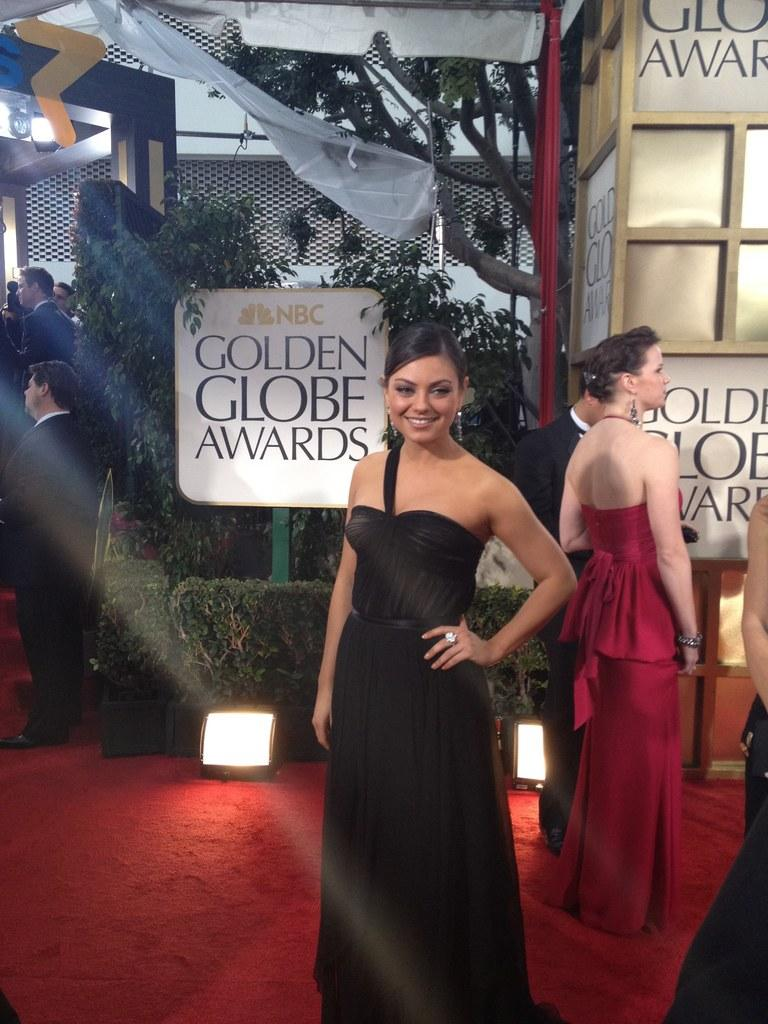How many people are in the image? There are three persons standing in the image. What are the people wearing? The persons are wearing clothes. What is in front of the plant? There is a board and lights in front of the plant. Where are the majority of the people located in the image? Two persons are on the left side of the image. What type of coal is being distributed by the persons in the image? There is no coal present in the image, and the persons are not distributing anything. 